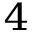Convert formula to latex. <formula><loc_0><loc_0><loc_500><loc_500>^ { 4 }</formula> 